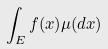Convert formula to latex. <formula><loc_0><loc_0><loc_500><loc_500>\int _ { E } f ( x ) \mu ( d x )</formula> 